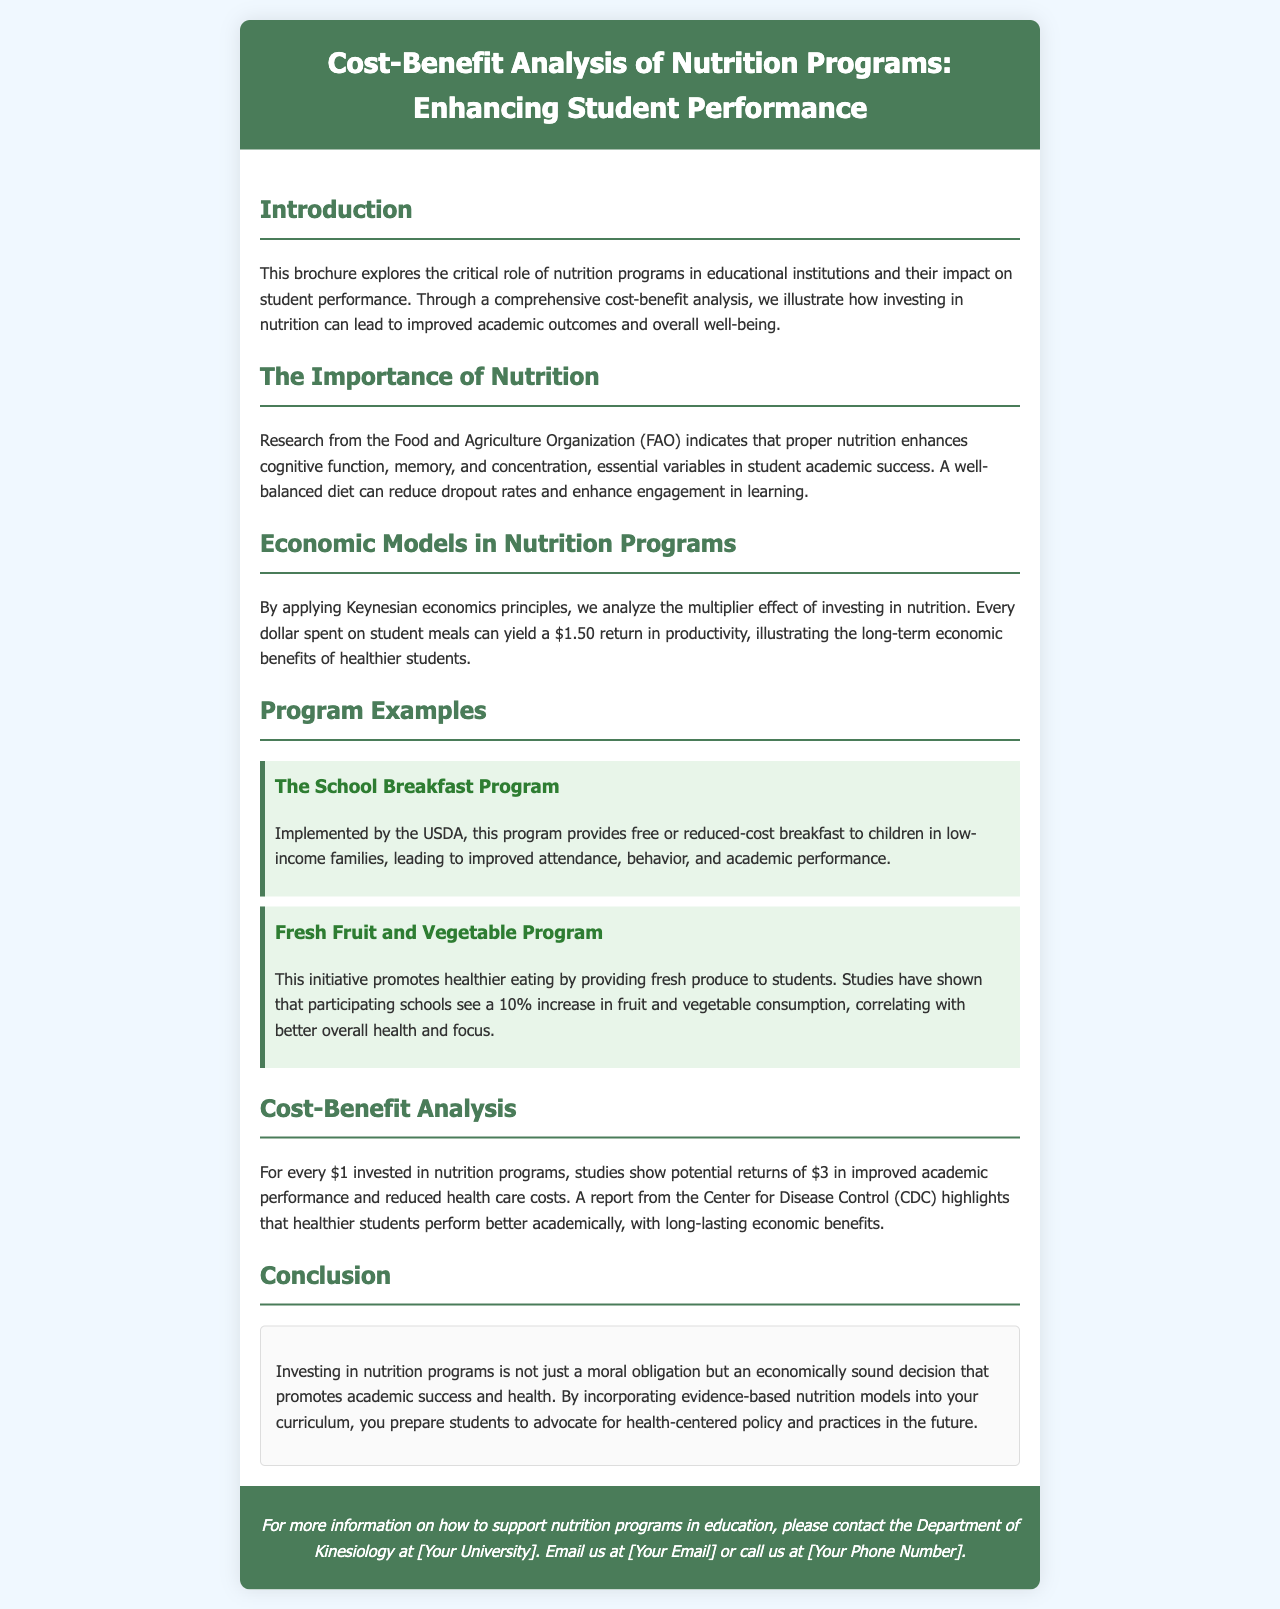what is the title of the brochure? The title is mentioned at the top of the document in the header section.
Answer: Cost-Benefit Analysis of Nutrition Programs: Enhancing Student Performance what organization implemented the School Breakfast Program? The document specifies the organization responsible for the program.
Answer: USDA what is the potential return for every dollar invested in nutrition programs? The document states a specific return related to investment in nutrition programs.
Answer: $3 what percentage increase in fruit and vegetable consumption is reported from the Fresh Fruit and Vegetable Program? The document cites a specific percentage associated with the program's impact on consumption.
Answer: 10% what economic theory is applied in analyzing the impact of nutrition programs? The document refers to a specific economic model that is relevant to the analysis.
Answer: Keynesian economics what are the two primary benefits identified with investing in nutrition programs? The document outlines two key outcomes resulting from these investments, leading to academic and health benefits.
Answer: Academic performance and health care costs what is the conclusion of the brochure regarding nutrition programs? The conclusion section sums up the stance on nutrition programs as mentioned in the document.
Answer: Economically sound decision 